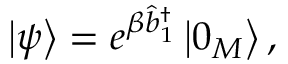Convert formula to latex. <formula><loc_0><loc_0><loc_500><loc_500>\left | \psi \right \rangle = e ^ { \beta \hat { b } _ { 1 } ^ { \dagger } } \left | 0 _ { M } \right \rangle ,</formula> 